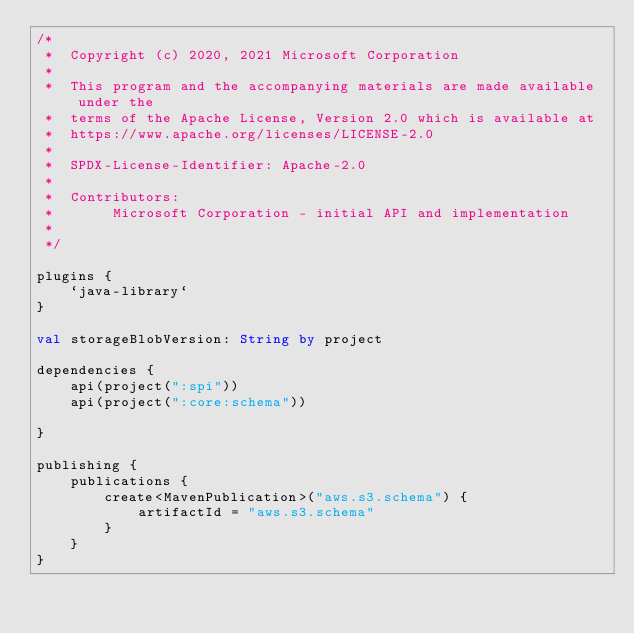Convert code to text. <code><loc_0><loc_0><loc_500><loc_500><_Kotlin_>/*
 *  Copyright (c) 2020, 2021 Microsoft Corporation
 *
 *  This program and the accompanying materials are made available under the
 *  terms of the Apache License, Version 2.0 which is available at
 *  https://www.apache.org/licenses/LICENSE-2.0
 *
 *  SPDX-License-Identifier: Apache-2.0
 *
 *  Contributors:
 *       Microsoft Corporation - initial API and implementation
 *
 */

plugins {
    `java-library`
}

val storageBlobVersion: String by project

dependencies {
    api(project(":spi"))
    api(project(":core:schema"))

}

publishing {
    publications {
        create<MavenPublication>("aws.s3.schema") {
            artifactId = "aws.s3.schema"
        }
    }
}
</code> 